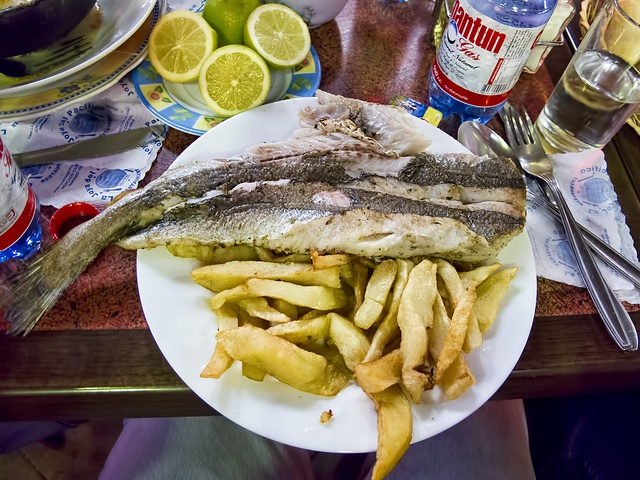Describe the objects in this image and their specific colors. I can see dining table in black, olive, lightgray, darkgray, and maroon tones, people in olive, gray, black, and purple tones, bowl in olive, black, darkgreen, gray, and darkgray tones, bottle in olive, lightgray, maroon, darkgray, and gray tones, and cup in olive, gray, black, darkgray, and tan tones in this image. 